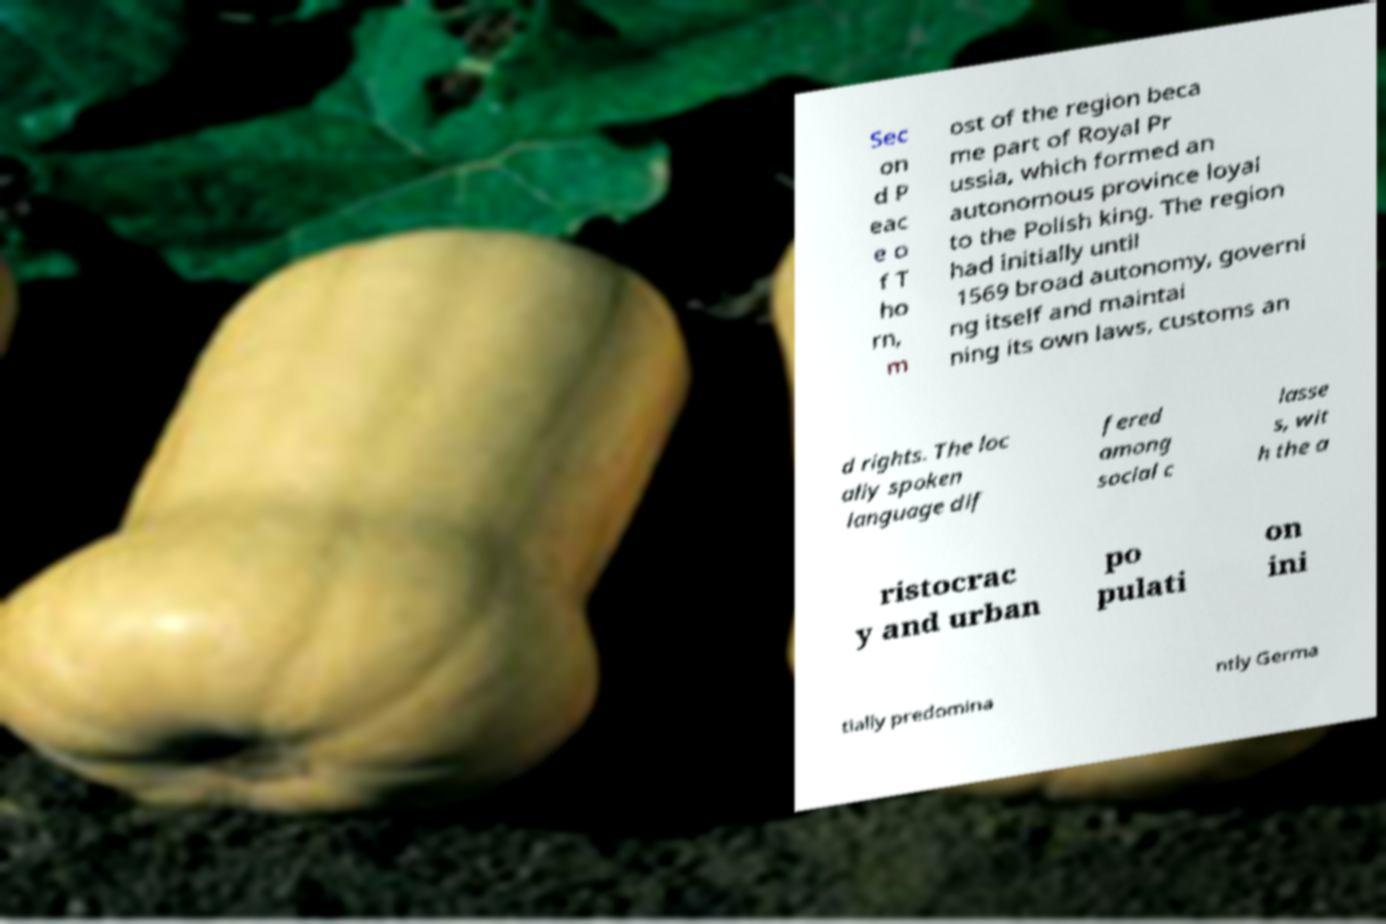I need the written content from this picture converted into text. Can you do that? Sec on d P eac e o f T ho rn, m ost of the region beca me part of Royal Pr ussia, which formed an autonomous province loyal to the Polish king. The region had initially until 1569 broad autonomy, governi ng itself and maintai ning its own laws, customs an d rights. The loc ally spoken language dif fered among social c lasse s, wit h the a ristocrac y and urban po pulati on ini tially predomina ntly Germa 